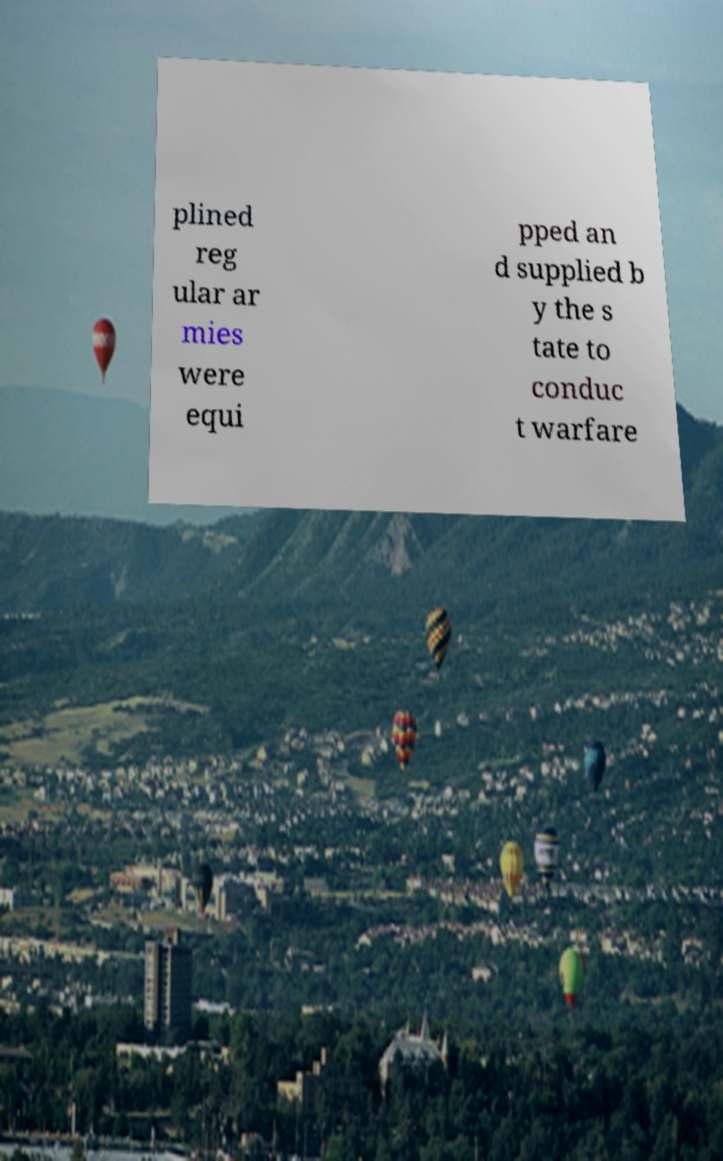Can you accurately transcribe the text from the provided image for me? plined reg ular ar mies were equi pped an d supplied b y the s tate to conduc t warfare 